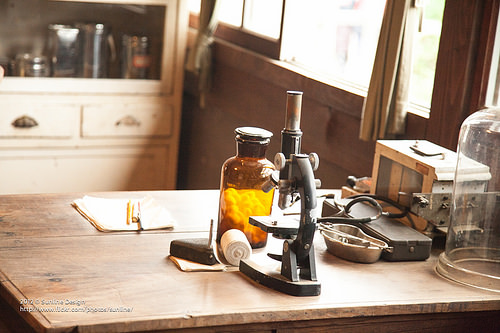<image>
Is the microscope behind the cotton? No. The microscope is not behind the cotton. From this viewpoint, the microscope appears to be positioned elsewhere in the scene. 